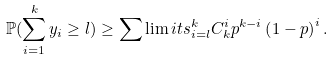Convert formula to latex. <formula><loc_0><loc_0><loc_500><loc_500>\mathbb { P } ( \sum _ { i = 1 } ^ { k } y _ { i } \geq l ) \geq \sum \lim i t s _ { i = l } ^ { k } C ^ { i } _ { k } p ^ { k - i } \left ( 1 - p \right ) ^ { i } .</formula> 